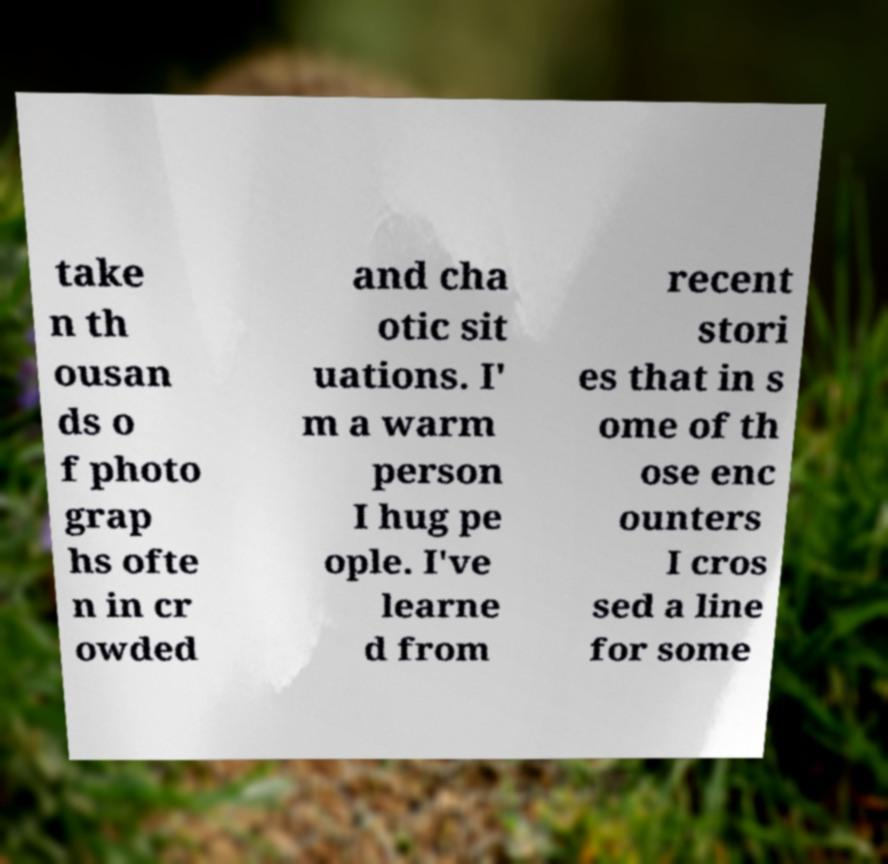For documentation purposes, I need the text within this image transcribed. Could you provide that? take n th ousan ds o f photo grap hs ofte n in cr owded and cha otic sit uations. I' m a warm person I hug pe ople. I've learne d from recent stori es that in s ome of th ose enc ounters I cros sed a line for some 